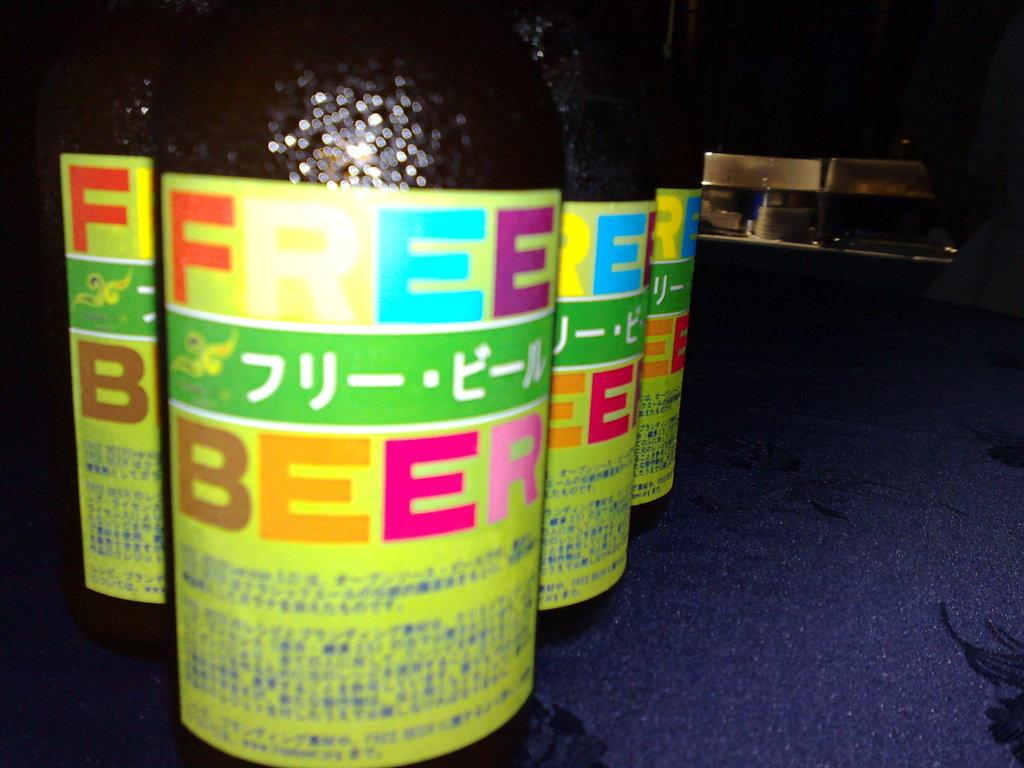<image>
Relay a brief, clear account of the picture shown. 4 bottles of Free Beer with colorful labels. 